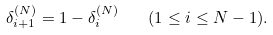Convert formula to latex. <formula><loc_0><loc_0><loc_500><loc_500>\delta _ { i + 1 } ^ { ( N ) } = 1 - \delta _ { i } ^ { ( N ) } \quad ( 1 \leq i \leq N - 1 ) .</formula> 